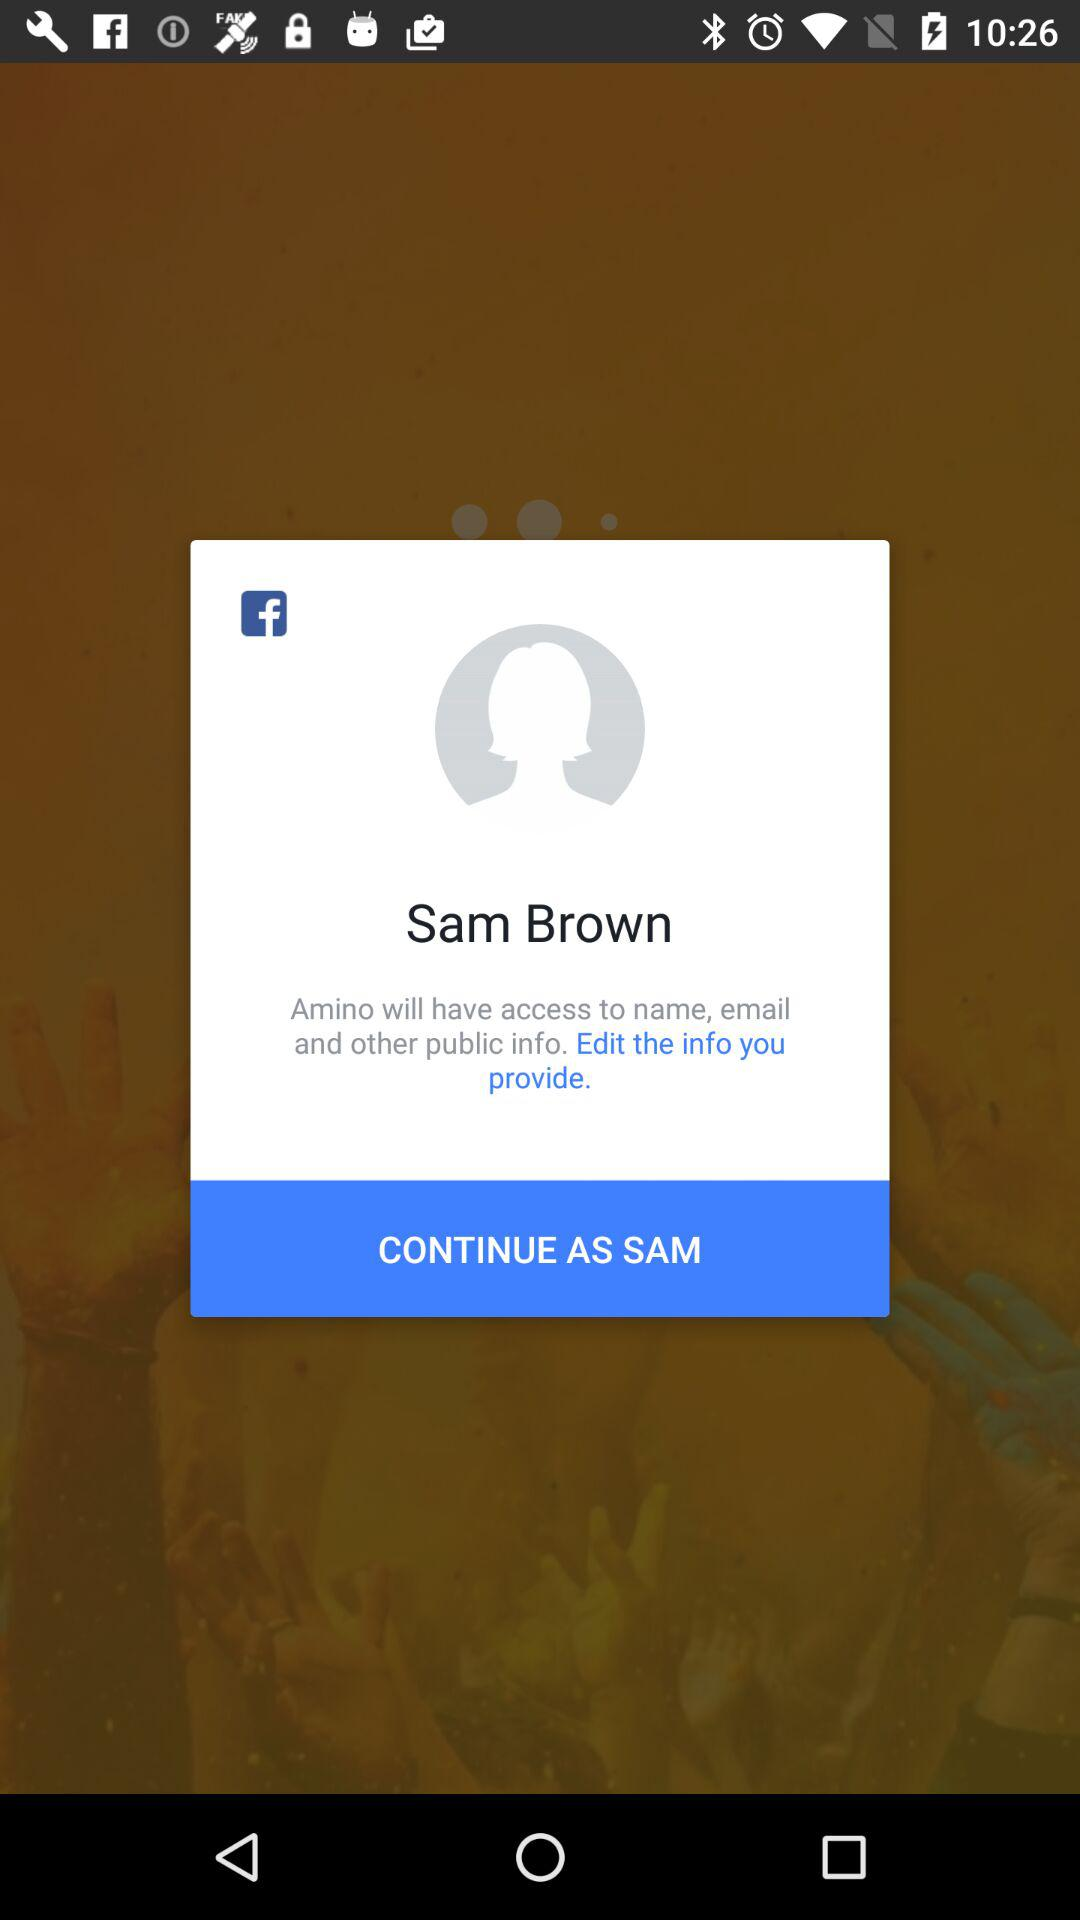Who will have access to names, emails and other public info.? Names, emails and other public info. will be accessible to "Amino". 